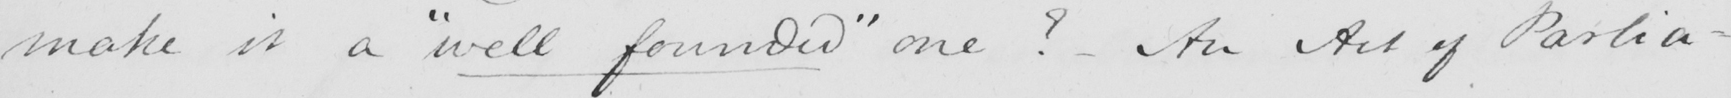What text is written in this handwritten line? make it a  " well founded "  one ?  - An Act of Parlia- 